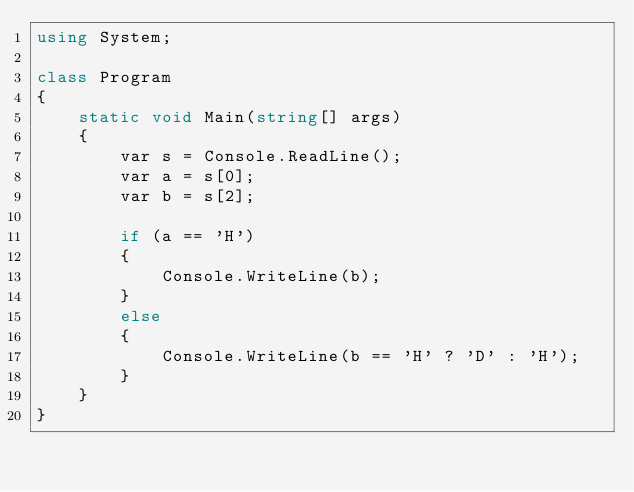Convert code to text. <code><loc_0><loc_0><loc_500><loc_500><_C#_>using System;

class Program
{
    static void Main(string[] args)
    {
        var s = Console.ReadLine();
        var a = s[0];
        var b = s[2];

        if (a == 'H')
        {
            Console.WriteLine(b);
        }
        else
        {
            Console.WriteLine(b == 'H' ? 'D' : 'H');
        }
    }
}
</code> 